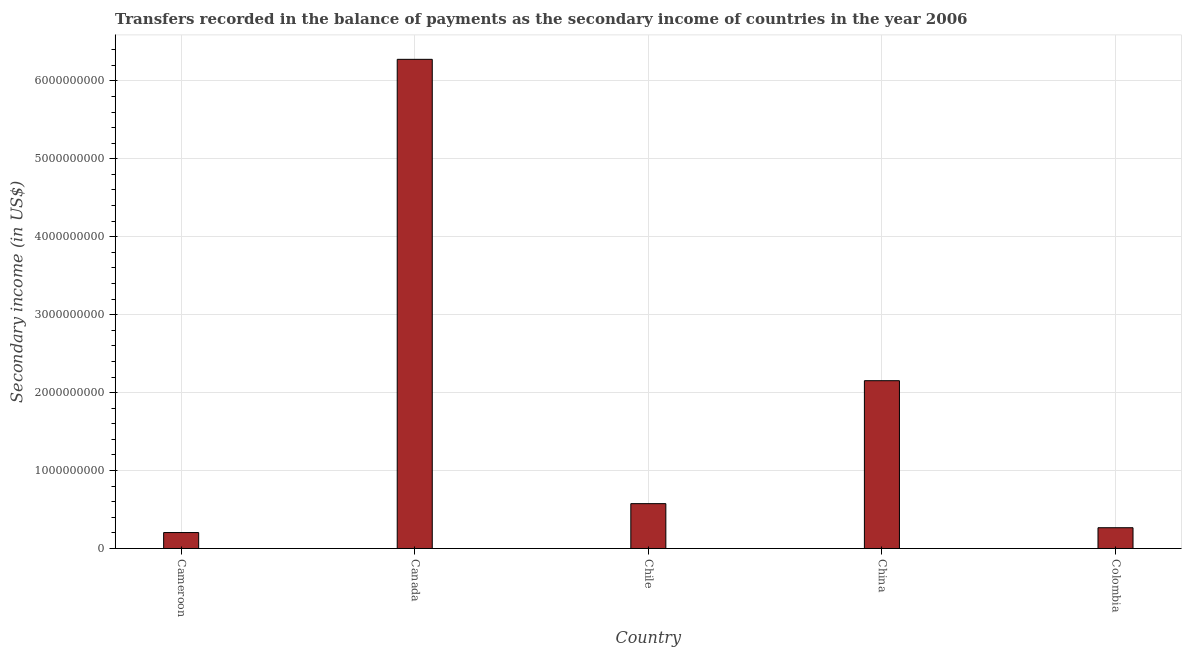What is the title of the graph?
Ensure brevity in your answer.  Transfers recorded in the balance of payments as the secondary income of countries in the year 2006. What is the label or title of the X-axis?
Your answer should be very brief. Country. What is the label or title of the Y-axis?
Your answer should be compact. Secondary income (in US$). What is the amount of secondary income in Colombia?
Ensure brevity in your answer.  2.66e+08. Across all countries, what is the maximum amount of secondary income?
Give a very brief answer. 6.28e+09. Across all countries, what is the minimum amount of secondary income?
Offer a very short reply. 2.04e+08. In which country was the amount of secondary income minimum?
Make the answer very short. Cameroon. What is the sum of the amount of secondary income?
Provide a short and direct response. 9.48e+09. What is the difference between the amount of secondary income in Chile and Colombia?
Provide a short and direct response. 3.09e+08. What is the average amount of secondary income per country?
Keep it short and to the point. 1.90e+09. What is the median amount of secondary income?
Your answer should be compact. 5.75e+08. In how many countries, is the amount of secondary income greater than 6200000000 US$?
Your response must be concise. 1. What is the ratio of the amount of secondary income in Canada to that in China?
Offer a terse response. 2.92. Is the difference between the amount of secondary income in Cameroon and Canada greater than the difference between any two countries?
Offer a terse response. Yes. What is the difference between the highest and the second highest amount of secondary income?
Keep it short and to the point. 4.12e+09. Is the sum of the amount of secondary income in Chile and Colombia greater than the maximum amount of secondary income across all countries?
Your answer should be compact. No. What is the difference between the highest and the lowest amount of secondary income?
Your answer should be very brief. 6.07e+09. How many bars are there?
Your answer should be very brief. 5. Are all the bars in the graph horizontal?
Ensure brevity in your answer.  No. What is the Secondary income (in US$) in Cameroon?
Your answer should be compact. 2.04e+08. What is the Secondary income (in US$) in Canada?
Your answer should be very brief. 6.28e+09. What is the Secondary income (in US$) in Chile?
Make the answer very short. 5.75e+08. What is the Secondary income (in US$) in China?
Keep it short and to the point. 2.15e+09. What is the Secondary income (in US$) of Colombia?
Your response must be concise. 2.66e+08. What is the difference between the Secondary income (in US$) in Cameroon and Canada?
Give a very brief answer. -6.07e+09. What is the difference between the Secondary income (in US$) in Cameroon and Chile?
Keep it short and to the point. -3.71e+08. What is the difference between the Secondary income (in US$) in Cameroon and China?
Give a very brief answer. -1.95e+09. What is the difference between the Secondary income (in US$) in Cameroon and Colombia?
Make the answer very short. -6.19e+07. What is the difference between the Secondary income (in US$) in Canada and Chile?
Provide a short and direct response. 5.70e+09. What is the difference between the Secondary income (in US$) in Canada and China?
Give a very brief answer. 4.12e+09. What is the difference between the Secondary income (in US$) in Canada and Colombia?
Your response must be concise. 6.01e+09. What is the difference between the Secondary income (in US$) in Chile and China?
Give a very brief answer. -1.58e+09. What is the difference between the Secondary income (in US$) in Chile and Colombia?
Keep it short and to the point. 3.09e+08. What is the difference between the Secondary income (in US$) in China and Colombia?
Keep it short and to the point. 1.89e+09. What is the ratio of the Secondary income (in US$) in Cameroon to that in Canada?
Offer a very short reply. 0.03. What is the ratio of the Secondary income (in US$) in Cameroon to that in Chile?
Provide a succinct answer. 0.35. What is the ratio of the Secondary income (in US$) in Cameroon to that in China?
Make the answer very short. 0.1. What is the ratio of the Secondary income (in US$) in Cameroon to that in Colombia?
Provide a succinct answer. 0.77. What is the ratio of the Secondary income (in US$) in Canada to that in Chile?
Make the answer very short. 10.91. What is the ratio of the Secondary income (in US$) in Canada to that in China?
Give a very brief answer. 2.92. What is the ratio of the Secondary income (in US$) in Canada to that in Colombia?
Your answer should be compact. 23.56. What is the ratio of the Secondary income (in US$) in Chile to that in China?
Make the answer very short. 0.27. What is the ratio of the Secondary income (in US$) in Chile to that in Colombia?
Provide a succinct answer. 2.16. What is the ratio of the Secondary income (in US$) in China to that in Colombia?
Give a very brief answer. 8.08. 